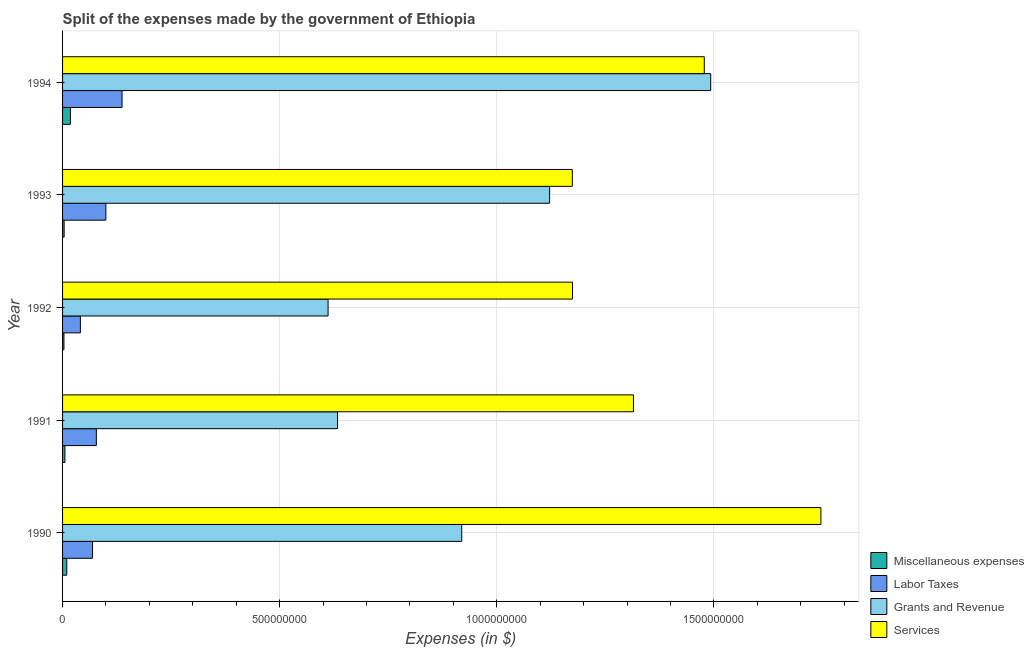Are the number of bars on each tick of the Y-axis equal?
Your answer should be compact. Yes. How many bars are there on the 2nd tick from the bottom?
Keep it short and to the point. 4. What is the label of the 3rd group of bars from the top?
Your answer should be very brief. 1992. What is the amount spent on labor taxes in 1991?
Offer a terse response. 7.78e+07. Across all years, what is the maximum amount spent on labor taxes?
Provide a succinct answer. 1.37e+08. Across all years, what is the minimum amount spent on miscellaneous expenses?
Ensure brevity in your answer.  3.20e+06. In which year was the amount spent on miscellaneous expenses minimum?
Your answer should be very brief. 1992. What is the total amount spent on grants and revenue in the graph?
Provide a short and direct response. 4.78e+09. What is the difference between the amount spent on labor taxes in 1990 and that in 1992?
Offer a terse response. 2.80e+07. What is the difference between the amount spent on labor taxes in 1991 and the amount spent on miscellaneous expenses in 1992?
Provide a succinct answer. 7.46e+07. What is the average amount spent on grants and revenue per year?
Offer a very short reply. 9.56e+08. In the year 1990, what is the difference between the amount spent on labor taxes and amount spent on services?
Provide a succinct answer. -1.68e+09. In how many years, is the amount spent on labor taxes greater than 500000000 $?
Ensure brevity in your answer.  0. What is the ratio of the amount spent on miscellaneous expenses in 1991 to that in 1992?
Your answer should be very brief. 1.69. Is the amount spent on labor taxes in 1993 less than that in 1994?
Offer a terse response. Yes. Is the difference between the amount spent on labor taxes in 1990 and 1994 greater than the difference between the amount spent on services in 1990 and 1994?
Keep it short and to the point. No. What is the difference between the highest and the second highest amount spent on miscellaneous expenses?
Your answer should be compact. 8.40e+06. What is the difference between the highest and the lowest amount spent on services?
Keep it short and to the point. 5.72e+08. In how many years, is the amount spent on miscellaneous expenses greater than the average amount spent on miscellaneous expenses taken over all years?
Provide a short and direct response. 2. Is the sum of the amount spent on grants and revenue in 1990 and 1991 greater than the maximum amount spent on miscellaneous expenses across all years?
Offer a terse response. Yes. Is it the case that in every year, the sum of the amount spent on miscellaneous expenses and amount spent on labor taxes is greater than the sum of amount spent on grants and revenue and amount spent on services?
Your answer should be very brief. No. What does the 3rd bar from the top in 1992 represents?
Ensure brevity in your answer.  Labor Taxes. What does the 1st bar from the bottom in 1994 represents?
Keep it short and to the point. Miscellaneous expenses. Are the values on the major ticks of X-axis written in scientific E-notation?
Give a very brief answer. No. Does the graph contain any zero values?
Provide a succinct answer. No. Does the graph contain grids?
Your answer should be very brief. Yes. What is the title of the graph?
Your answer should be very brief. Split of the expenses made by the government of Ethiopia. Does "United Kingdom" appear as one of the legend labels in the graph?
Keep it short and to the point. No. What is the label or title of the X-axis?
Provide a short and direct response. Expenses (in $). What is the label or title of the Y-axis?
Offer a terse response. Year. What is the Expenses (in $) in Miscellaneous expenses in 1990?
Provide a succinct answer. 9.70e+06. What is the Expenses (in $) of Labor Taxes in 1990?
Keep it short and to the point. 6.90e+07. What is the Expenses (in $) in Grants and Revenue in 1990?
Offer a terse response. 9.19e+08. What is the Expenses (in $) in Services in 1990?
Your answer should be compact. 1.75e+09. What is the Expenses (in $) of Miscellaneous expenses in 1991?
Make the answer very short. 5.40e+06. What is the Expenses (in $) of Labor Taxes in 1991?
Your answer should be very brief. 7.78e+07. What is the Expenses (in $) of Grants and Revenue in 1991?
Give a very brief answer. 6.33e+08. What is the Expenses (in $) of Services in 1991?
Offer a very short reply. 1.31e+09. What is the Expenses (in $) of Miscellaneous expenses in 1992?
Offer a very short reply. 3.20e+06. What is the Expenses (in $) of Labor Taxes in 1992?
Offer a terse response. 4.10e+07. What is the Expenses (in $) in Grants and Revenue in 1992?
Your answer should be compact. 6.12e+08. What is the Expenses (in $) of Services in 1992?
Ensure brevity in your answer.  1.17e+09. What is the Expenses (in $) of Miscellaneous expenses in 1993?
Your response must be concise. 3.60e+06. What is the Expenses (in $) of Labor Taxes in 1993?
Your response must be concise. 9.97e+07. What is the Expenses (in $) of Grants and Revenue in 1993?
Provide a short and direct response. 1.12e+09. What is the Expenses (in $) of Services in 1993?
Offer a very short reply. 1.17e+09. What is the Expenses (in $) in Miscellaneous expenses in 1994?
Your response must be concise. 1.81e+07. What is the Expenses (in $) of Labor Taxes in 1994?
Offer a very short reply. 1.37e+08. What is the Expenses (in $) in Grants and Revenue in 1994?
Provide a succinct answer. 1.49e+09. What is the Expenses (in $) in Services in 1994?
Give a very brief answer. 1.48e+09. Across all years, what is the maximum Expenses (in $) in Miscellaneous expenses?
Offer a very short reply. 1.81e+07. Across all years, what is the maximum Expenses (in $) in Labor Taxes?
Your response must be concise. 1.37e+08. Across all years, what is the maximum Expenses (in $) of Grants and Revenue?
Your answer should be compact. 1.49e+09. Across all years, what is the maximum Expenses (in $) in Services?
Provide a short and direct response. 1.75e+09. Across all years, what is the minimum Expenses (in $) of Miscellaneous expenses?
Ensure brevity in your answer.  3.20e+06. Across all years, what is the minimum Expenses (in $) in Labor Taxes?
Offer a terse response. 4.10e+07. Across all years, what is the minimum Expenses (in $) in Grants and Revenue?
Your answer should be very brief. 6.12e+08. Across all years, what is the minimum Expenses (in $) in Services?
Make the answer very short. 1.17e+09. What is the total Expenses (in $) in Miscellaneous expenses in the graph?
Give a very brief answer. 4.00e+07. What is the total Expenses (in $) in Labor Taxes in the graph?
Keep it short and to the point. 4.24e+08. What is the total Expenses (in $) in Grants and Revenue in the graph?
Give a very brief answer. 4.78e+09. What is the total Expenses (in $) in Services in the graph?
Your answer should be compact. 6.89e+09. What is the difference between the Expenses (in $) of Miscellaneous expenses in 1990 and that in 1991?
Your answer should be compact. 4.30e+06. What is the difference between the Expenses (in $) in Labor Taxes in 1990 and that in 1991?
Offer a very short reply. -8.80e+06. What is the difference between the Expenses (in $) of Grants and Revenue in 1990 and that in 1991?
Give a very brief answer. 2.86e+08. What is the difference between the Expenses (in $) in Services in 1990 and that in 1991?
Offer a very short reply. 4.32e+08. What is the difference between the Expenses (in $) of Miscellaneous expenses in 1990 and that in 1992?
Give a very brief answer. 6.50e+06. What is the difference between the Expenses (in $) of Labor Taxes in 1990 and that in 1992?
Give a very brief answer. 2.80e+07. What is the difference between the Expenses (in $) in Grants and Revenue in 1990 and that in 1992?
Give a very brief answer. 3.08e+08. What is the difference between the Expenses (in $) of Services in 1990 and that in 1992?
Ensure brevity in your answer.  5.72e+08. What is the difference between the Expenses (in $) in Miscellaneous expenses in 1990 and that in 1993?
Offer a very short reply. 6.10e+06. What is the difference between the Expenses (in $) of Labor Taxes in 1990 and that in 1993?
Provide a short and direct response. -3.07e+07. What is the difference between the Expenses (in $) in Grants and Revenue in 1990 and that in 1993?
Provide a succinct answer. -2.02e+08. What is the difference between the Expenses (in $) in Services in 1990 and that in 1993?
Your answer should be very brief. 5.72e+08. What is the difference between the Expenses (in $) of Miscellaneous expenses in 1990 and that in 1994?
Offer a terse response. -8.40e+06. What is the difference between the Expenses (in $) of Labor Taxes in 1990 and that in 1994?
Ensure brevity in your answer.  -6.80e+07. What is the difference between the Expenses (in $) in Grants and Revenue in 1990 and that in 1994?
Provide a succinct answer. -5.73e+08. What is the difference between the Expenses (in $) in Services in 1990 and that in 1994?
Make the answer very short. 2.69e+08. What is the difference between the Expenses (in $) of Miscellaneous expenses in 1991 and that in 1992?
Provide a short and direct response. 2.20e+06. What is the difference between the Expenses (in $) of Labor Taxes in 1991 and that in 1992?
Your answer should be very brief. 3.68e+07. What is the difference between the Expenses (in $) of Grants and Revenue in 1991 and that in 1992?
Provide a short and direct response. 2.18e+07. What is the difference between the Expenses (in $) of Services in 1991 and that in 1992?
Your response must be concise. 1.40e+08. What is the difference between the Expenses (in $) in Miscellaneous expenses in 1991 and that in 1993?
Your response must be concise. 1.80e+06. What is the difference between the Expenses (in $) of Labor Taxes in 1991 and that in 1993?
Provide a succinct answer. -2.19e+07. What is the difference between the Expenses (in $) in Grants and Revenue in 1991 and that in 1993?
Your answer should be compact. -4.88e+08. What is the difference between the Expenses (in $) of Services in 1991 and that in 1993?
Provide a short and direct response. 1.41e+08. What is the difference between the Expenses (in $) of Miscellaneous expenses in 1991 and that in 1994?
Offer a terse response. -1.27e+07. What is the difference between the Expenses (in $) in Labor Taxes in 1991 and that in 1994?
Your answer should be very brief. -5.92e+07. What is the difference between the Expenses (in $) of Grants and Revenue in 1991 and that in 1994?
Keep it short and to the point. -8.59e+08. What is the difference between the Expenses (in $) of Services in 1991 and that in 1994?
Provide a succinct answer. -1.63e+08. What is the difference between the Expenses (in $) of Miscellaneous expenses in 1992 and that in 1993?
Provide a succinct answer. -4.00e+05. What is the difference between the Expenses (in $) in Labor Taxes in 1992 and that in 1993?
Provide a succinct answer. -5.87e+07. What is the difference between the Expenses (in $) in Grants and Revenue in 1992 and that in 1993?
Provide a succinct answer. -5.10e+08. What is the difference between the Expenses (in $) in Miscellaneous expenses in 1992 and that in 1994?
Provide a short and direct response. -1.49e+07. What is the difference between the Expenses (in $) in Labor Taxes in 1992 and that in 1994?
Your answer should be compact. -9.60e+07. What is the difference between the Expenses (in $) of Grants and Revenue in 1992 and that in 1994?
Provide a succinct answer. -8.81e+08. What is the difference between the Expenses (in $) in Services in 1992 and that in 1994?
Ensure brevity in your answer.  -3.04e+08. What is the difference between the Expenses (in $) in Miscellaneous expenses in 1993 and that in 1994?
Provide a short and direct response. -1.45e+07. What is the difference between the Expenses (in $) in Labor Taxes in 1993 and that in 1994?
Offer a very short reply. -3.73e+07. What is the difference between the Expenses (in $) of Grants and Revenue in 1993 and that in 1994?
Provide a short and direct response. -3.71e+08. What is the difference between the Expenses (in $) in Services in 1993 and that in 1994?
Give a very brief answer. -3.04e+08. What is the difference between the Expenses (in $) in Miscellaneous expenses in 1990 and the Expenses (in $) in Labor Taxes in 1991?
Your answer should be very brief. -6.81e+07. What is the difference between the Expenses (in $) in Miscellaneous expenses in 1990 and the Expenses (in $) in Grants and Revenue in 1991?
Provide a short and direct response. -6.24e+08. What is the difference between the Expenses (in $) of Miscellaneous expenses in 1990 and the Expenses (in $) of Services in 1991?
Provide a succinct answer. -1.31e+09. What is the difference between the Expenses (in $) of Labor Taxes in 1990 and the Expenses (in $) of Grants and Revenue in 1991?
Give a very brief answer. -5.64e+08. What is the difference between the Expenses (in $) of Labor Taxes in 1990 and the Expenses (in $) of Services in 1991?
Make the answer very short. -1.25e+09. What is the difference between the Expenses (in $) of Grants and Revenue in 1990 and the Expenses (in $) of Services in 1991?
Your answer should be very brief. -3.96e+08. What is the difference between the Expenses (in $) in Miscellaneous expenses in 1990 and the Expenses (in $) in Labor Taxes in 1992?
Ensure brevity in your answer.  -3.13e+07. What is the difference between the Expenses (in $) in Miscellaneous expenses in 1990 and the Expenses (in $) in Grants and Revenue in 1992?
Offer a terse response. -6.02e+08. What is the difference between the Expenses (in $) of Miscellaneous expenses in 1990 and the Expenses (in $) of Services in 1992?
Keep it short and to the point. -1.16e+09. What is the difference between the Expenses (in $) of Labor Taxes in 1990 and the Expenses (in $) of Grants and Revenue in 1992?
Provide a short and direct response. -5.42e+08. What is the difference between the Expenses (in $) of Labor Taxes in 1990 and the Expenses (in $) of Services in 1992?
Your answer should be compact. -1.11e+09. What is the difference between the Expenses (in $) in Grants and Revenue in 1990 and the Expenses (in $) in Services in 1992?
Keep it short and to the point. -2.55e+08. What is the difference between the Expenses (in $) in Miscellaneous expenses in 1990 and the Expenses (in $) in Labor Taxes in 1993?
Ensure brevity in your answer.  -9.00e+07. What is the difference between the Expenses (in $) in Miscellaneous expenses in 1990 and the Expenses (in $) in Grants and Revenue in 1993?
Your answer should be compact. -1.11e+09. What is the difference between the Expenses (in $) in Miscellaneous expenses in 1990 and the Expenses (in $) in Services in 1993?
Provide a succinct answer. -1.16e+09. What is the difference between the Expenses (in $) of Labor Taxes in 1990 and the Expenses (in $) of Grants and Revenue in 1993?
Your answer should be compact. -1.05e+09. What is the difference between the Expenses (in $) in Labor Taxes in 1990 and the Expenses (in $) in Services in 1993?
Give a very brief answer. -1.10e+09. What is the difference between the Expenses (in $) in Grants and Revenue in 1990 and the Expenses (in $) in Services in 1993?
Give a very brief answer. -2.55e+08. What is the difference between the Expenses (in $) in Miscellaneous expenses in 1990 and the Expenses (in $) in Labor Taxes in 1994?
Keep it short and to the point. -1.27e+08. What is the difference between the Expenses (in $) of Miscellaneous expenses in 1990 and the Expenses (in $) of Grants and Revenue in 1994?
Your answer should be compact. -1.48e+09. What is the difference between the Expenses (in $) in Miscellaneous expenses in 1990 and the Expenses (in $) in Services in 1994?
Keep it short and to the point. -1.47e+09. What is the difference between the Expenses (in $) of Labor Taxes in 1990 and the Expenses (in $) of Grants and Revenue in 1994?
Provide a succinct answer. -1.42e+09. What is the difference between the Expenses (in $) of Labor Taxes in 1990 and the Expenses (in $) of Services in 1994?
Provide a short and direct response. -1.41e+09. What is the difference between the Expenses (in $) in Grants and Revenue in 1990 and the Expenses (in $) in Services in 1994?
Provide a short and direct response. -5.59e+08. What is the difference between the Expenses (in $) in Miscellaneous expenses in 1991 and the Expenses (in $) in Labor Taxes in 1992?
Your answer should be very brief. -3.56e+07. What is the difference between the Expenses (in $) in Miscellaneous expenses in 1991 and the Expenses (in $) in Grants and Revenue in 1992?
Keep it short and to the point. -6.06e+08. What is the difference between the Expenses (in $) in Miscellaneous expenses in 1991 and the Expenses (in $) in Services in 1992?
Provide a succinct answer. -1.17e+09. What is the difference between the Expenses (in $) in Labor Taxes in 1991 and the Expenses (in $) in Grants and Revenue in 1992?
Ensure brevity in your answer.  -5.34e+08. What is the difference between the Expenses (in $) of Labor Taxes in 1991 and the Expenses (in $) of Services in 1992?
Your answer should be very brief. -1.10e+09. What is the difference between the Expenses (in $) of Grants and Revenue in 1991 and the Expenses (in $) of Services in 1992?
Offer a terse response. -5.41e+08. What is the difference between the Expenses (in $) of Miscellaneous expenses in 1991 and the Expenses (in $) of Labor Taxes in 1993?
Ensure brevity in your answer.  -9.43e+07. What is the difference between the Expenses (in $) of Miscellaneous expenses in 1991 and the Expenses (in $) of Grants and Revenue in 1993?
Your response must be concise. -1.12e+09. What is the difference between the Expenses (in $) of Miscellaneous expenses in 1991 and the Expenses (in $) of Services in 1993?
Provide a succinct answer. -1.17e+09. What is the difference between the Expenses (in $) in Labor Taxes in 1991 and the Expenses (in $) in Grants and Revenue in 1993?
Make the answer very short. -1.04e+09. What is the difference between the Expenses (in $) in Labor Taxes in 1991 and the Expenses (in $) in Services in 1993?
Ensure brevity in your answer.  -1.10e+09. What is the difference between the Expenses (in $) in Grants and Revenue in 1991 and the Expenses (in $) in Services in 1993?
Offer a very short reply. -5.41e+08. What is the difference between the Expenses (in $) in Miscellaneous expenses in 1991 and the Expenses (in $) in Labor Taxes in 1994?
Provide a succinct answer. -1.32e+08. What is the difference between the Expenses (in $) of Miscellaneous expenses in 1991 and the Expenses (in $) of Grants and Revenue in 1994?
Offer a very short reply. -1.49e+09. What is the difference between the Expenses (in $) in Miscellaneous expenses in 1991 and the Expenses (in $) in Services in 1994?
Provide a short and direct response. -1.47e+09. What is the difference between the Expenses (in $) of Labor Taxes in 1991 and the Expenses (in $) of Grants and Revenue in 1994?
Provide a succinct answer. -1.41e+09. What is the difference between the Expenses (in $) of Labor Taxes in 1991 and the Expenses (in $) of Services in 1994?
Give a very brief answer. -1.40e+09. What is the difference between the Expenses (in $) of Grants and Revenue in 1991 and the Expenses (in $) of Services in 1994?
Provide a succinct answer. -8.45e+08. What is the difference between the Expenses (in $) in Miscellaneous expenses in 1992 and the Expenses (in $) in Labor Taxes in 1993?
Your response must be concise. -9.65e+07. What is the difference between the Expenses (in $) in Miscellaneous expenses in 1992 and the Expenses (in $) in Grants and Revenue in 1993?
Ensure brevity in your answer.  -1.12e+09. What is the difference between the Expenses (in $) of Miscellaneous expenses in 1992 and the Expenses (in $) of Services in 1993?
Provide a short and direct response. -1.17e+09. What is the difference between the Expenses (in $) in Labor Taxes in 1992 and the Expenses (in $) in Grants and Revenue in 1993?
Keep it short and to the point. -1.08e+09. What is the difference between the Expenses (in $) of Labor Taxes in 1992 and the Expenses (in $) of Services in 1993?
Provide a succinct answer. -1.13e+09. What is the difference between the Expenses (in $) in Grants and Revenue in 1992 and the Expenses (in $) in Services in 1993?
Offer a terse response. -5.62e+08. What is the difference between the Expenses (in $) in Miscellaneous expenses in 1992 and the Expenses (in $) in Labor Taxes in 1994?
Give a very brief answer. -1.34e+08. What is the difference between the Expenses (in $) in Miscellaneous expenses in 1992 and the Expenses (in $) in Grants and Revenue in 1994?
Keep it short and to the point. -1.49e+09. What is the difference between the Expenses (in $) of Miscellaneous expenses in 1992 and the Expenses (in $) of Services in 1994?
Provide a succinct answer. -1.47e+09. What is the difference between the Expenses (in $) of Labor Taxes in 1992 and the Expenses (in $) of Grants and Revenue in 1994?
Provide a short and direct response. -1.45e+09. What is the difference between the Expenses (in $) of Labor Taxes in 1992 and the Expenses (in $) of Services in 1994?
Offer a very short reply. -1.44e+09. What is the difference between the Expenses (in $) of Grants and Revenue in 1992 and the Expenses (in $) of Services in 1994?
Make the answer very short. -8.66e+08. What is the difference between the Expenses (in $) in Miscellaneous expenses in 1993 and the Expenses (in $) in Labor Taxes in 1994?
Make the answer very short. -1.33e+08. What is the difference between the Expenses (in $) of Miscellaneous expenses in 1993 and the Expenses (in $) of Grants and Revenue in 1994?
Give a very brief answer. -1.49e+09. What is the difference between the Expenses (in $) in Miscellaneous expenses in 1993 and the Expenses (in $) in Services in 1994?
Your response must be concise. -1.47e+09. What is the difference between the Expenses (in $) in Labor Taxes in 1993 and the Expenses (in $) in Grants and Revenue in 1994?
Your answer should be compact. -1.39e+09. What is the difference between the Expenses (in $) in Labor Taxes in 1993 and the Expenses (in $) in Services in 1994?
Offer a terse response. -1.38e+09. What is the difference between the Expenses (in $) in Grants and Revenue in 1993 and the Expenses (in $) in Services in 1994?
Keep it short and to the point. -3.56e+08. What is the average Expenses (in $) of Labor Taxes per year?
Keep it short and to the point. 8.49e+07. What is the average Expenses (in $) in Grants and Revenue per year?
Ensure brevity in your answer.  9.56e+08. What is the average Expenses (in $) of Services per year?
Provide a short and direct response. 1.38e+09. In the year 1990, what is the difference between the Expenses (in $) of Miscellaneous expenses and Expenses (in $) of Labor Taxes?
Provide a succinct answer. -5.93e+07. In the year 1990, what is the difference between the Expenses (in $) of Miscellaneous expenses and Expenses (in $) of Grants and Revenue?
Ensure brevity in your answer.  -9.10e+08. In the year 1990, what is the difference between the Expenses (in $) in Miscellaneous expenses and Expenses (in $) in Services?
Offer a terse response. -1.74e+09. In the year 1990, what is the difference between the Expenses (in $) in Labor Taxes and Expenses (in $) in Grants and Revenue?
Provide a succinct answer. -8.50e+08. In the year 1990, what is the difference between the Expenses (in $) of Labor Taxes and Expenses (in $) of Services?
Your answer should be very brief. -1.68e+09. In the year 1990, what is the difference between the Expenses (in $) in Grants and Revenue and Expenses (in $) in Services?
Give a very brief answer. -8.27e+08. In the year 1991, what is the difference between the Expenses (in $) of Miscellaneous expenses and Expenses (in $) of Labor Taxes?
Your answer should be very brief. -7.24e+07. In the year 1991, what is the difference between the Expenses (in $) of Miscellaneous expenses and Expenses (in $) of Grants and Revenue?
Keep it short and to the point. -6.28e+08. In the year 1991, what is the difference between the Expenses (in $) in Miscellaneous expenses and Expenses (in $) in Services?
Offer a very short reply. -1.31e+09. In the year 1991, what is the difference between the Expenses (in $) in Labor Taxes and Expenses (in $) in Grants and Revenue?
Give a very brief answer. -5.56e+08. In the year 1991, what is the difference between the Expenses (in $) of Labor Taxes and Expenses (in $) of Services?
Make the answer very short. -1.24e+09. In the year 1991, what is the difference between the Expenses (in $) of Grants and Revenue and Expenses (in $) of Services?
Offer a very short reply. -6.82e+08. In the year 1992, what is the difference between the Expenses (in $) in Miscellaneous expenses and Expenses (in $) in Labor Taxes?
Make the answer very short. -3.78e+07. In the year 1992, what is the difference between the Expenses (in $) of Miscellaneous expenses and Expenses (in $) of Grants and Revenue?
Provide a succinct answer. -6.08e+08. In the year 1992, what is the difference between the Expenses (in $) of Miscellaneous expenses and Expenses (in $) of Services?
Keep it short and to the point. -1.17e+09. In the year 1992, what is the difference between the Expenses (in $) in Labor Taxes and Expenses (in $) in Grants and Revenue?
Keep it short and to the point. -5.70e+08. In the year 1992, what is the difference between the Expenses (in $) of Labor Taxes and Expenses (in $) of Services?
Keep it short and to the point. -1.13e+09. In the year 1992, what is the difference between the Expenses (in $) of Grants and Revenue and Expenses (in $) of Services?
Your answer should be compact. -5.63e+08. In the year 1993, what is the difference between the Expenses (in $) of Miscellaneous expenses and Expenses (in $) of Labor Taxes?
Your answer should be compact. -9.61e+07. In the year 1993, what is the difference between the Expenses (in $) in Miscellaneous expenses and Expenses (in $) in Grants and Revenue?
Make the answer very short. -1.12e+09. In the year 1993, what is the difference between the Expenses (in $) of Miscellaneous expenses and Expenses (in $) of Services?
Give a very brief answer. -1.17e+09. In the year 1993, what is the difference between the Expenses (in $) of Labor Taxes and Expenses (in $) of Grants and Revenue?
Provide a succinct answer. -1.02e+09. In the year 1993, what is the difference between the Expenses (in $) of Labor Taxes and Expenses (in $) of Services?
Provide a short and direct response. -1.07e+09. In the year 1993, what is the difference between the Expenses (in $) of Grants and Revenue and Expenses (in $) of Services?
Give a very brief answer. -5.23e+07. In the year 1994, what is the difference between the Expenses (in $) of Miscellaneous expenses and Expenses (in $) of Labor Taxes?
Keep it short and to the point. -1.19e+08. In the year 1994, what is the difference between the Expenses (in $) of Miscellaneous expenses and Expenses (in $) of Grants and Revenue?
Give a very brief answer. -1.47e+09. In the year 1994, what is the difference between the Expenses (in $) of Miscellaneous expenses and Expenses (in $) of Services?
Your response must be concise. -1.46e+09. In the year 1994, what is the difference between the Expenses (in $) in Labor Taxes and Expenses (in $) in Grants and Revenue?
Provide a succinct answer. -1.36e+09. In the year 1994, what is the difference between the Expenses (in $) in Labor Taxes and Expenses (in $) in Services?
Offer a very short reply. -1.34e+09. In the year 1994, what is the difference between the Expenses (in $) in Grants and Revenue and Expenses (in $) in Services?
Your answer should be very brief. 1.48e+07. What is the ratio of the Expenses (in $) in Miscellaneous expenses in 1990 to that in 1991?
Provide a succinct answer. 1.8. What is the ratio of the Expenses (in $) in Labor Taxes in 1990 to that in 1991?
Ensure brevity in your answer.  0.89. What is the ratio of the Expenses (in $) of Grants and Revenue in 1990 to that in 1991?
Provide a short and direct response. 1.45. What is the ratio of the Expenses (in $) of Services in 1990 to that in 1991?
Make the answer very short. 1.33. What is the ratio of the Expenses (in $) of Miscellaneous expenses in 1990 to that in 1992?
Keep it short and to the point. 3.03. What is the ratio of the Expenses (in $) of Labor Taxes in 1990 to that in 1992?
Ensure brevity in your answer.  1.68. What is the ratio of the Expenses (in $) in Grants and Revenue in 1990 to that in 1992?
Keep it short and to the point. 1.5. What is the ratio of the Expenses (in $) in Services in 1990 to that in 1992?
Your answer should be very brief. 1.49. What is the ratio of the Expenses (in $) of Miscellaneous expenses in 1990 to that in 1993?
Your answer should be compact. 2.69. What is the ratio of the Expenses (in $) of Labor Taxes in 1990 to that in 1993?
Your answer should be compact. 0.69. What is the ratio of the Expenses (in $) of Grants and Revenue in 1990 to that in 1993?
Give a very brief answer. 0.82. What is the ratio of the Expenses (in $) of Services in 1990 to that in 1993?
Your answer should be very brief. 1.49. What is the ratio of the Expenses (in $) in Miscellaneous expenses in 1990 to that in 1994?
Your answer should be very brief. 0.54. What is the ratio of the Expenses (in $) in Labor Taxes in 1990 to that in 1994?
Make the answer very short. 0.5. What is the ratio of the Expenses (in $) in Grants and Revenue in 1990 to that in 1994?
Provide a short and direct response. 0.62. What is the ratio of the Expenses (in $) of Services in 1990 to that in 1994?
Offer a very short reply. 1.18. What is the ratio of the Expenses (in $) of Miscellaneous expenses in 1991 to that in 1992?
Offer a very short reply. 1.69. What is the ratio of the Expenses (in $) in Labor Taxes in 1991 to that in 1992?
Offer a terse response. 1.9. What is the ratio of the Expenses (in $) in Grants and Revenue in 1991 to that in 1992?
Offer a terse response. 1.04. What is the ratio of the Expenses (in $) in Services in 1991 to that in 1992?
Offer a very short reply. 1.12. What is the ratio of the Expenses (in $) in Miscellaneous expenses in 1991 to that in 1993?
Offer a terse response. 1.5. What is the ratio of the Expenses (in $) in Labor Taxes in 1991 to that in 1993?
Ensure brevity in your answer.  0.78. What is the ratio of the Expenses (in $) of Grants and Revenue in 1991 to that in 1993?
Keep it short and to the point. 0.56. What is the ratio of the Expenses (in $) in Services in 1991 to that in 1993?
Make the answer very short. 1.12. What is the ratio of the Expenses (in $) in Miscellaneous expenses in 1991 to that in 1994?
Your answer should be compact. 0.3. What is the ratio of the Expenses (in $) of Labor Taxes in 1991 to that in 1994?
Your answer should be very brief. 0.57. What is the ratio of the Expenses (in $) of Grants and Revenue in 1991 to that in 1994?
Ensure brevity in your answer.  0.42. What is the ratio of the Expenses (in $) of Services in 1991 to that in 1994?
Ensure brevity in your answer.  0.89. What is the ratio of the Expenses (in $) of Miscellaneous expenses in 1992 to that in 1993?
Provide a short and direct response. 0.89. What is the ratio of the Expenses (in $) in Labor Taxes in 1992 to that in 1993?
Offer a very short reply. 0.41. What is the ratio of the Expenses (in $) in Grants and Revenue in 1992 to that in 1993?
Your answer should be very brief. 0.55. What is the ratio of the Expenses (in $) in Miscellaneous expenses in 1992 to that in 1994?
Provide a short and direct response. 0.18. What is the ratio of the Expenses (in $) in Labor Taxes in 1992 to that in 1994?
Provide a succinct answer. 0.3. What is the ratio of the Expenses (in $) in Grants and Revenue in 1992 to that in 1994?
Your answer should be very brief. 0.41. What is the ratio of the Expenses (in $) in Services in 1992 to that in 1994?
Provide a short and direct response. 0.79. What is the ratio of the Expenses (in $) of Miscellaneous expenses in 1993 to that in 1994?
Keep it short and to the point. 0.2. What is the ratio of the Expenses (in $) of Labor Taxes in 1993 to that in 1994?
Your answer should be compact. 0.73. What is the ratio of the Expenses (in $) in Grants and Revenue in 1993 to that in 1994?
Your response must be concise. 0.75. What is the ratio of the Expenses (in $) in Services in 1993 to that in 1994?
Give a very brief answer. 0.79. What is the difference between the highest and the second highest Expenses (in $) of Miscellaneous expenses?
Keep it short and to the point. 8.40e+06. What is the difference between the highest and the second highest Expenses (in $) in Labor Taxes?
Provide a succinct answer. 3.73e+07. What is the difference between the highest and the second highest Expenses (in $) in Grants and Revenue?
Keep it short and to the point. 3.71e+08. What is the difference between the highest and the second highest Expenses (in $) of Services?
Offer a very short reply. 2.69e+08. What is the difference between the highest and the lowest Expenses (in $) in Miscellaneous expenses?
Provide a short and direct response. 1.49e+07. What is the difference between the highest and the lowest Expenses (in $) in Labor Taxes?
Make the answer very short. 9.60e+07. What is the difference between the highest and the lowest Expenses (in $) of Grants and Revenue?
Give a very brief answer. 8.81e+08. What is the difference between the highest and the lowest Expenses (in $) in Services?
Your answer should be very brief. 5.72e+08. 